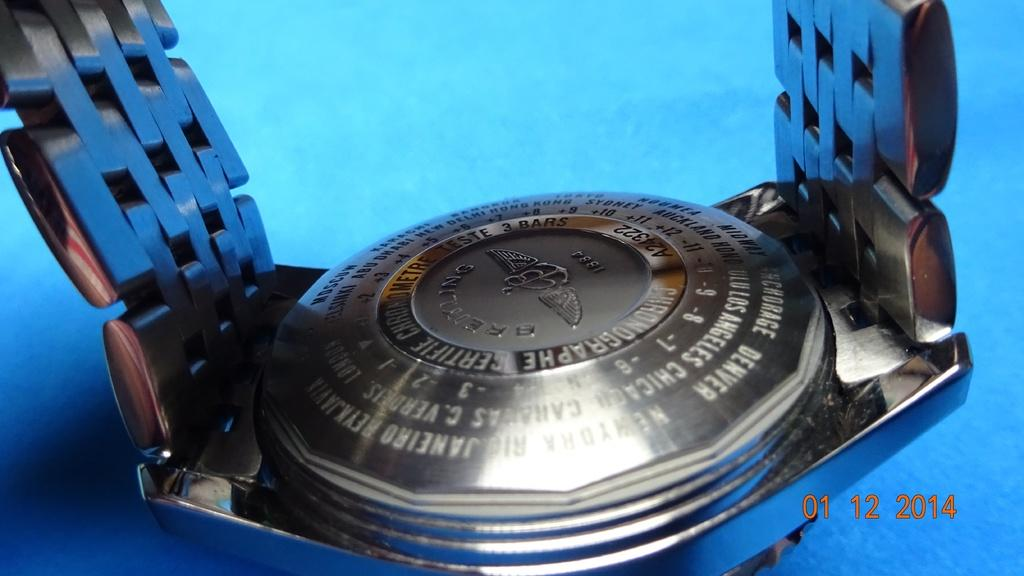<image>
Render a clear and concise summary of the photo. A Breitling watch sits on its face as the back is shown. 